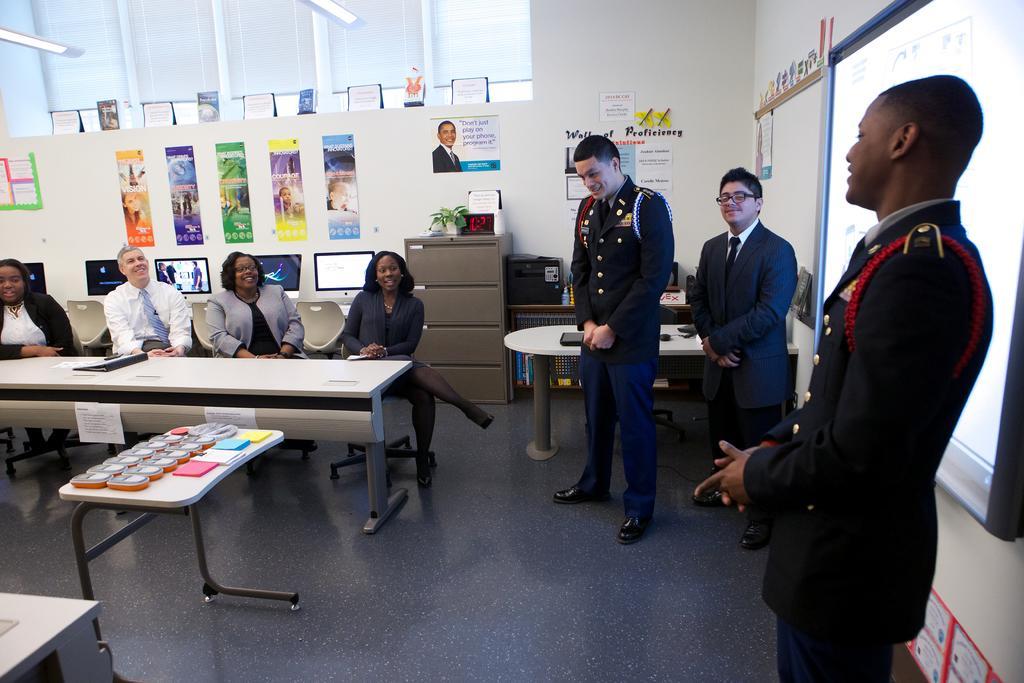Describe this image in one or two sentences. In this picture we can see the posters, wall, monitors. On the desk we can see a houseplant and boards. On the right side of the picture we can see the people are standing and we can see a screen. On the tables we can see few objects, file. On the left side of the picture we can see the people are sitting on the chairs and all are smiling. We can see the papers with some information. At the bottom portion of the picture we can see the floor and an object. 